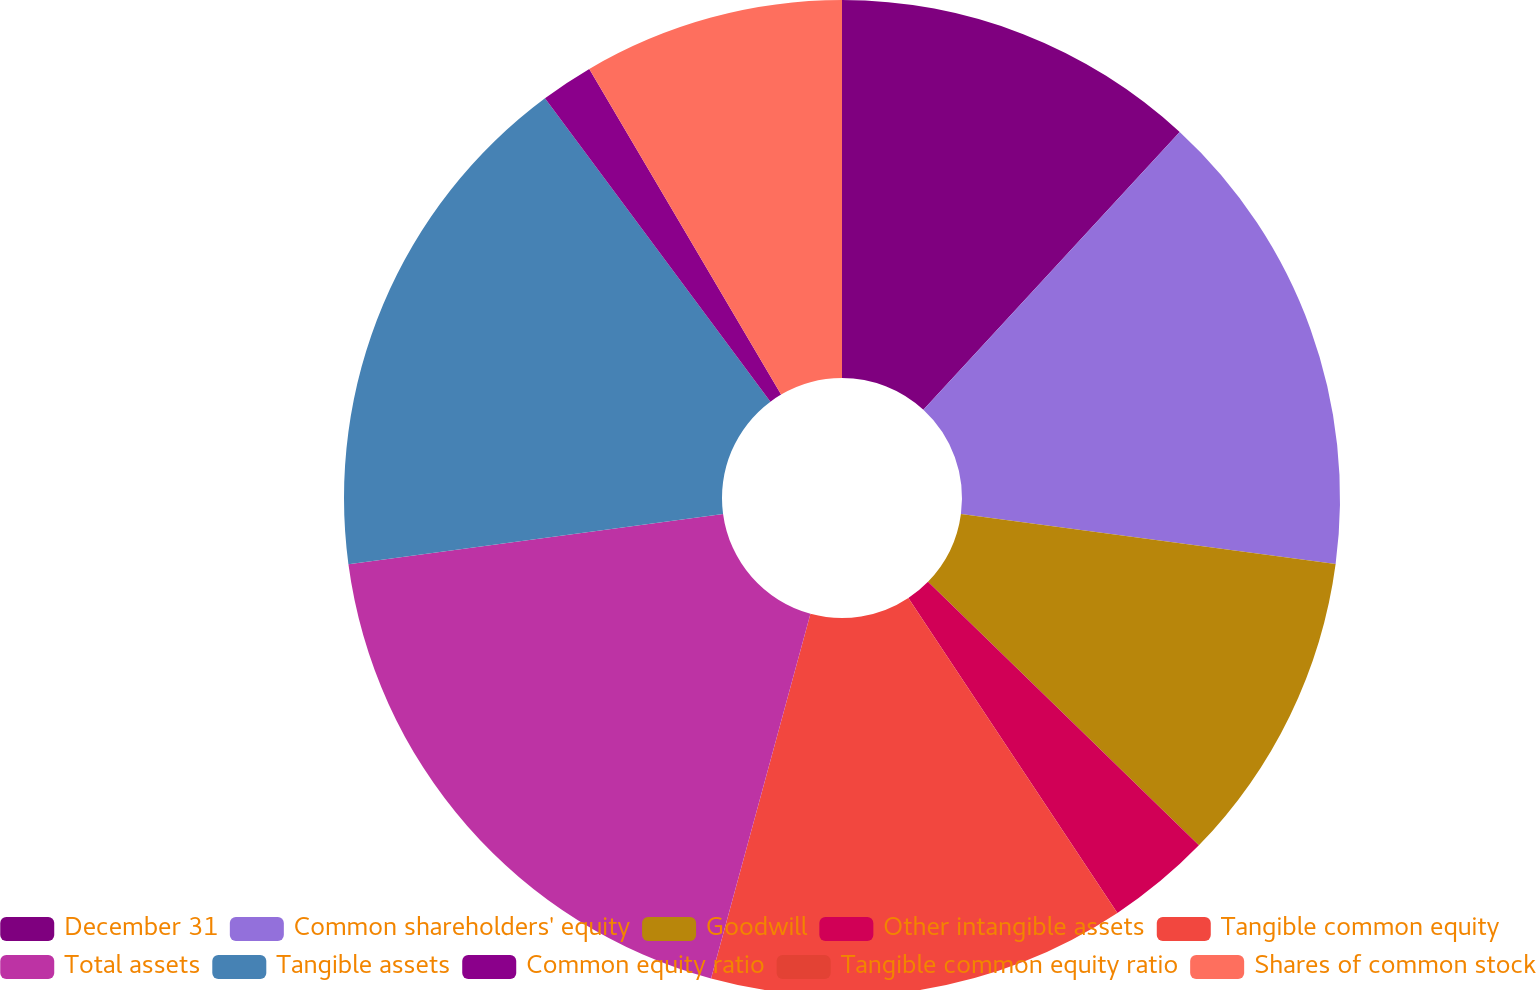Convert chart to OTSL. <chart><loc_0><loc_0><loc_500><loc_500><pie_chart><fcel>December 31<fcel>Common shareholders' equity<fcel>Goodwill<fcel>Other intangible assets<fcel>Tangible common equity<fcel>Total assets<fcel>Tangible assets<fcel>Common equity ratio<fcel>Tangible common equity ratio<fcel>Shares of common stock<nl><fcel>11.86%<fcel>15.25%<fcel>10.17%<fcel>3.39%<fcel>13.56%<fcel>18.64%<fcel>16.95%<fcel>1.7%<fcel>0.0%<fcel>8.47%<nl></chart> 